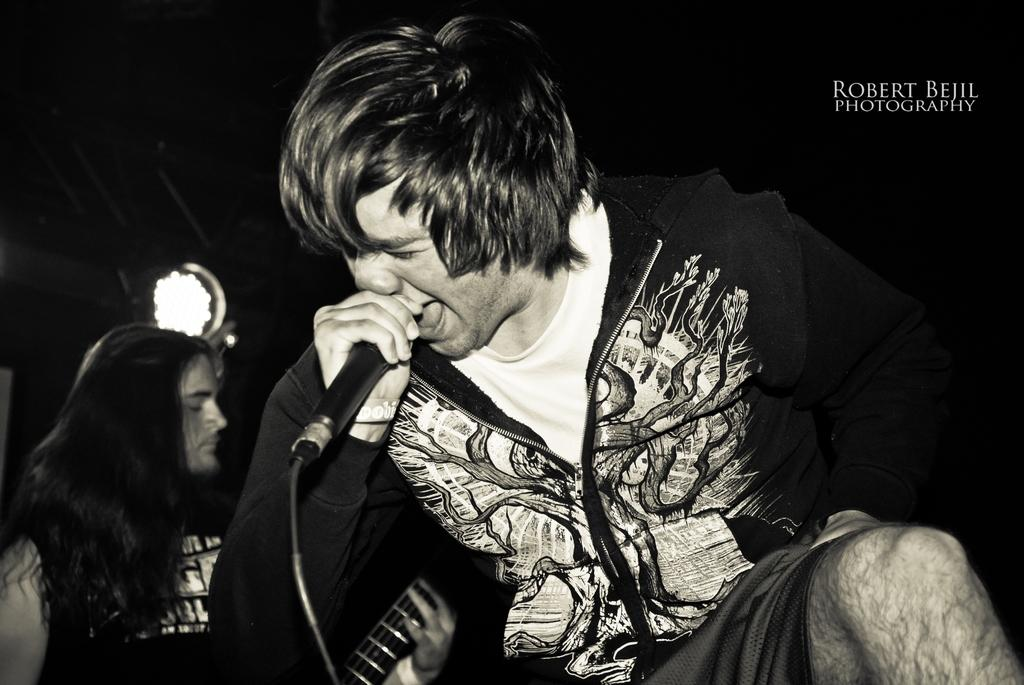What is the person in the image wearing? The person in the image is wearing a jacket. What is the person holding in the image? The person is holding a mic. Can you describe the position of the second person in the image? There is another person behind the first person. What can be seen in the background of the image? There is a light in the background of the image. What type of iron is the dad using in the image? There is no iron or dad present in the image. 